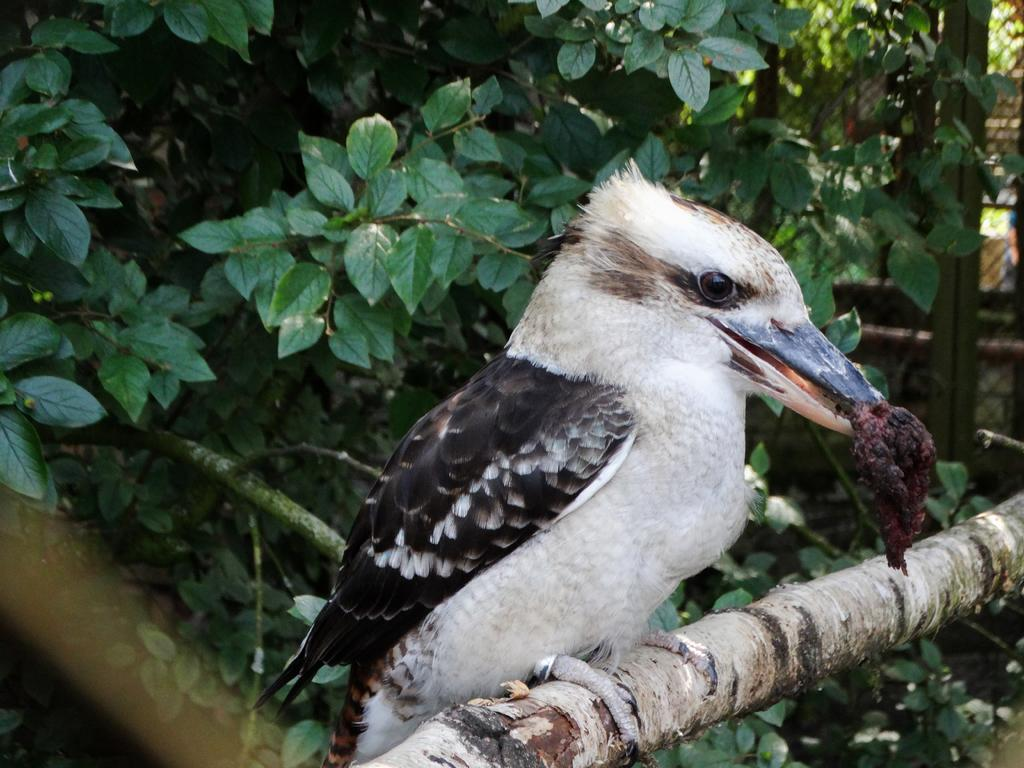What type of animal is present in the image? There is a bird in the image. What can be seen in the background of the image? Leaves are visible in the background of the image. What type of event is happening with the bean in the image? There is no bean present in the image, and therefore no event involving a bean can be observed. 